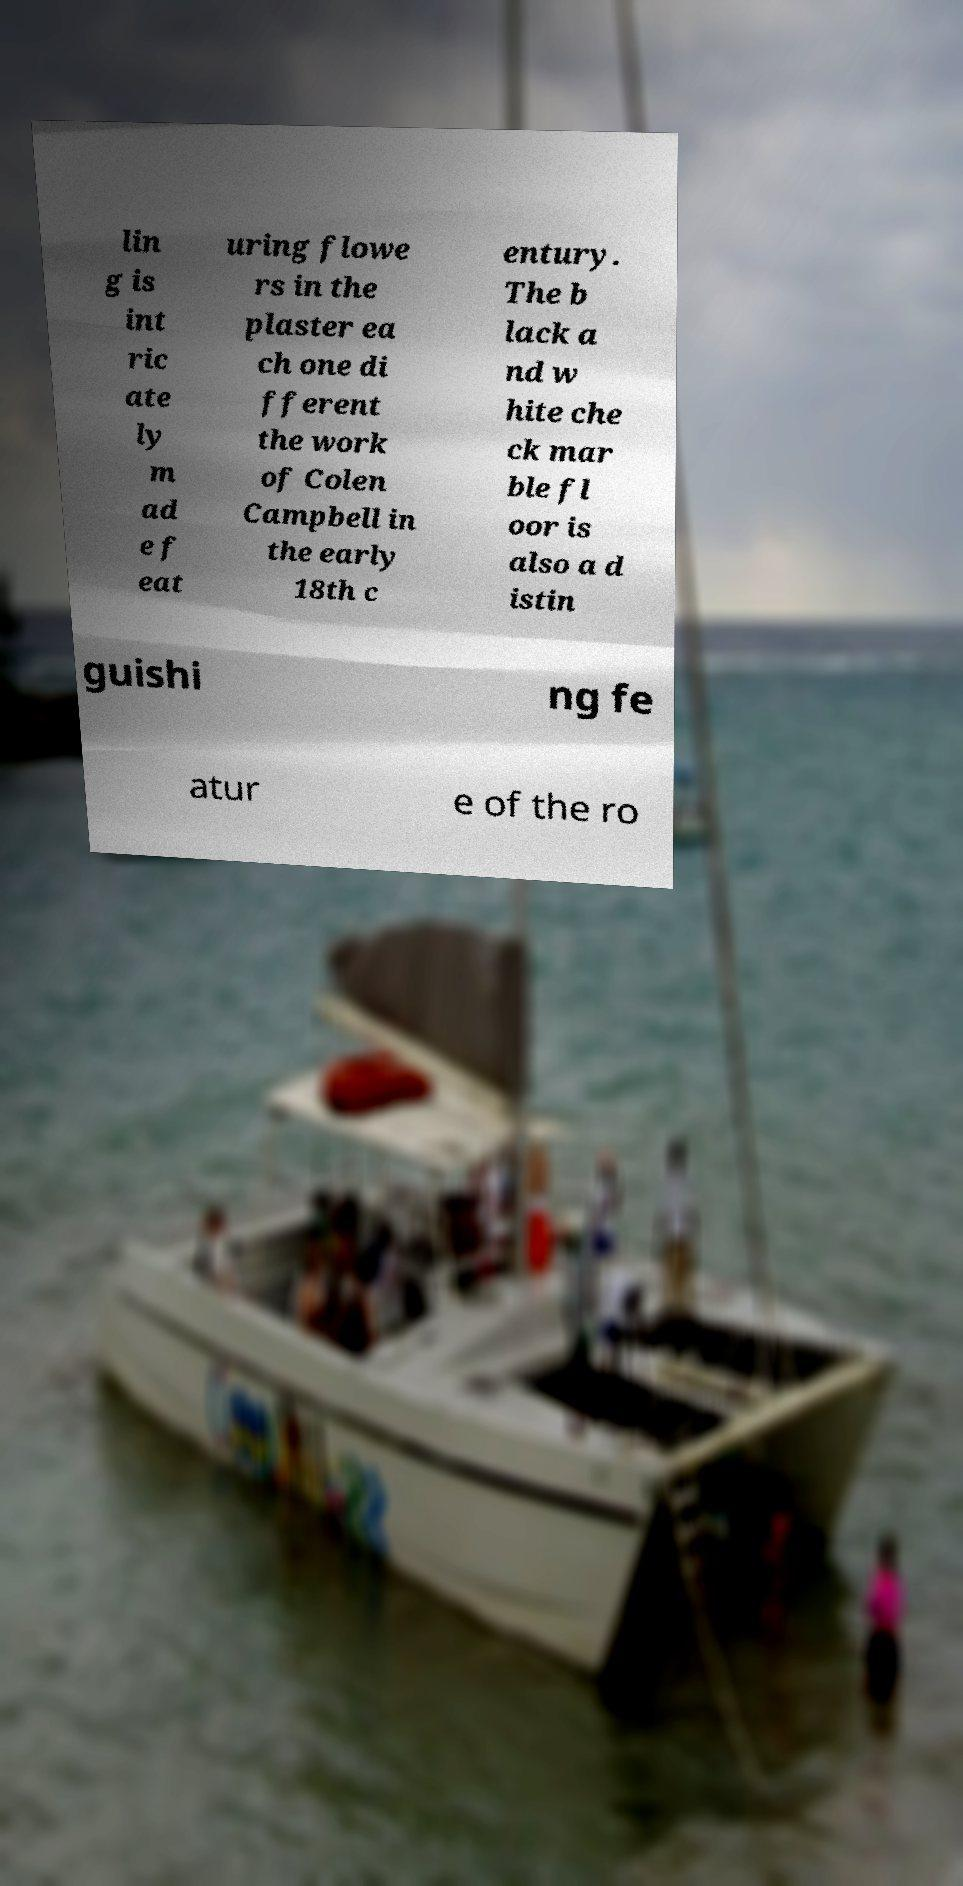Please identify and transcribe the text found in this image. lin g is int ric ate ly m ad e f eat uring flowe rs in the plaster ea ch one di fferent the work of Colen Campbell in the early 18th c entury. The b lack a nd w hite che ck mar ble fl oor is also a d istin guishi ng fe atur e of the ro 